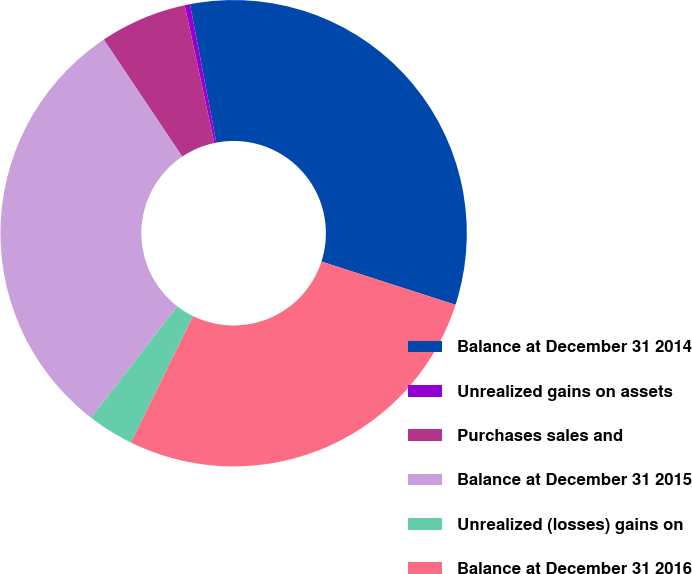Convert chart. <chart><loc_0><loc_0><loc_500><loc_500><pie_chart><fcel>Balance at December 31 2014<fcel>Unrealized gains on assets<fcel>Purchases sales and<fcel>Balance at December 31 2015<fcel>Unrealized (losses) gains on<fcel>Balance at December 31 2016<nl><fcel>32.96%<fcel>0.37%<fcel>6.04%<fcel>30.13%<fcel>3.21%<fcel>27.29%<nl></chart> 